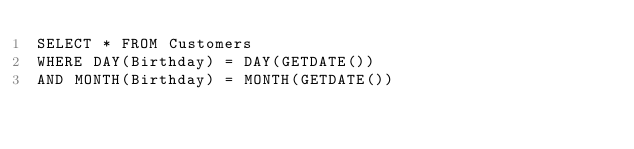<code> <loc_0><loc_0><loc_500><loc_500><_SQL_>SELECT * FROM Customers
WHERE DAY(Birthday) = DAY(GETDATE())
AND MONTH(Birthday) = MONTH(GETDATE())</code> 